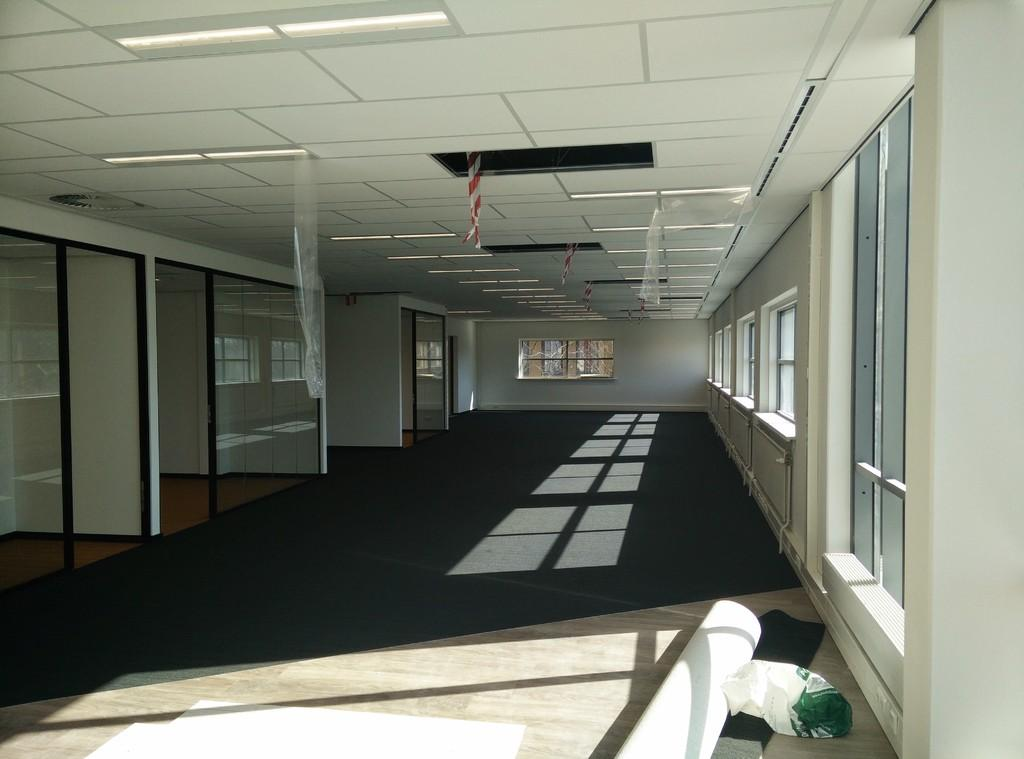What type of structures can be seen in the image? There are walls in the image. What type of objects are made of glass in the image? There are glass objects in the image. What allows natural light to enter the space in the image? There are windows in the image. What can be found on the floor in the image? There are objects on the floor in the image. What is visible above the walls and objects in the image? The ceiling is visible in the image. What provides illumination in the image? There are lights in the image. What type of coverings are present in the image? There are covers in the image. How does the pet interact with the glass objects in the image? There is no pet present in the image, so it cannot interact with the glass objects. What type of test is being conducted in the image? There is no test being conducted in the image; it features walls, glass objects, windows, objects on the floor, the ceiling, lights, and covers. 